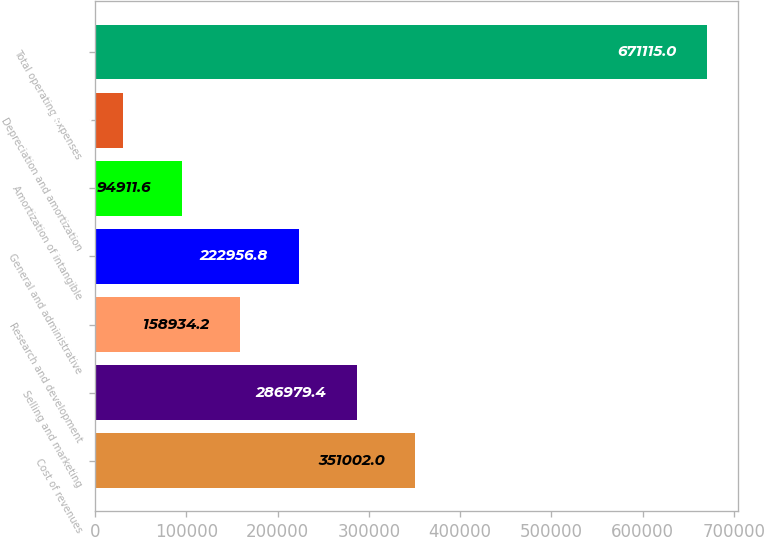Convert chart to OTSL. <chart><loc_0><loc_0><loc_500><loc_500><bar_chart><fcel>Cost of revenues<fcel>Selling and marketing<fcel>Research and development<fcel>General and administrative<fcel>Amortization of intangible<fcel>Depreciation and amortization<fcel>Total operating expenses<nl><fcel>351002<fcel>286979<fcel>158934<fcel>222957<fcel>94911.6<fcel>30889<fcel>671115<nl></chart> 